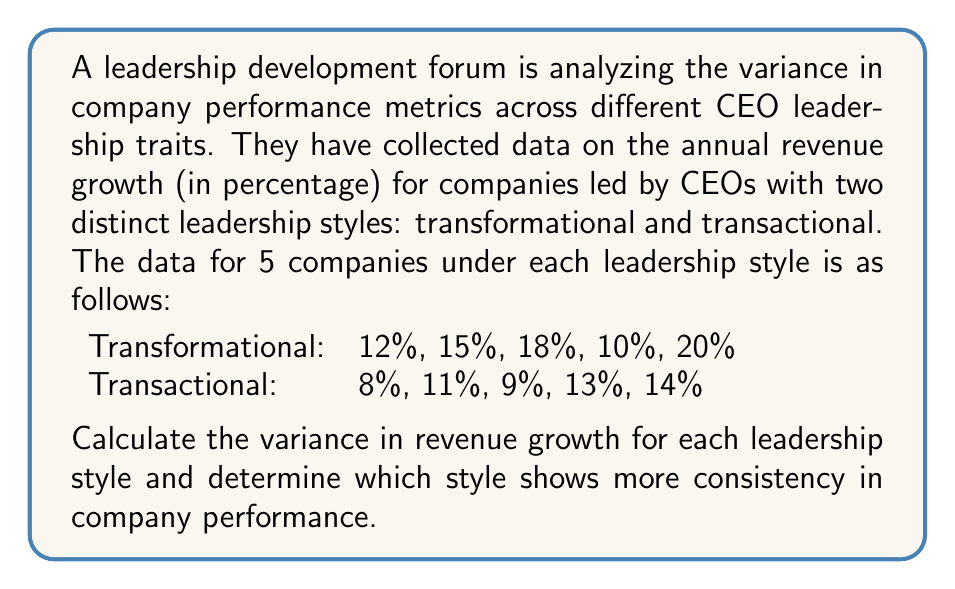What is the answer to this math problem? To solve this problem, we'll calculate the variance for each leadership style using the following steps:

1. Calculate the mean (average) revenue growth for each style.
2. Calculate the squared differences from the mean for each data point.
3. Find the average of these squared differences (variance).

For Transformational leadership:

1. Mean: $\mu_T = \frac{12 + 15 + 18 + 10 + 20}{5} = 15\%$

2. Squared differences:
   $(12 - 15)^2 = 9$
   $(15 - 15)^2 = 0$
   $(18 - 15)^2 = 9$
   $(10 - 15)^2 = 25$
   $(20 - 15)^2 = 25$

3. Variance: $\sigma_T^2 = \frac{9 + 0 + 9 + 25 + 25}{5} = 13.6$

For Transactional leadership:

1. Mean: $\mu_C = \frac{8 + 11 + 9 + 13 + 14}{5} = 11\%$

2. Squared differences:
   $(8 - 11)^2 = 9$
   $(11 - 11)^2 = 0$
   $(9 - 11)^2 = 4$
   $(13 - 11)^2 = 4$
   $(14 - 11)^2 = 9$

3. Variance: $\sigma_C^2 = \frac{9 + 0 + 4 + 4 + 9}{5} = 5.2$

The leadership style with the lower variance shows more consistency in company performance. In this case, the transactional leadership style has a lower variance (5.2) compared to the transformational leadership style (13.6).
Answer: Transformational: $\sigma_T^2 = 13.6$
Transactional: $\sigma_C^2 = 5.2$
Transactional leadership shows more consistency. 